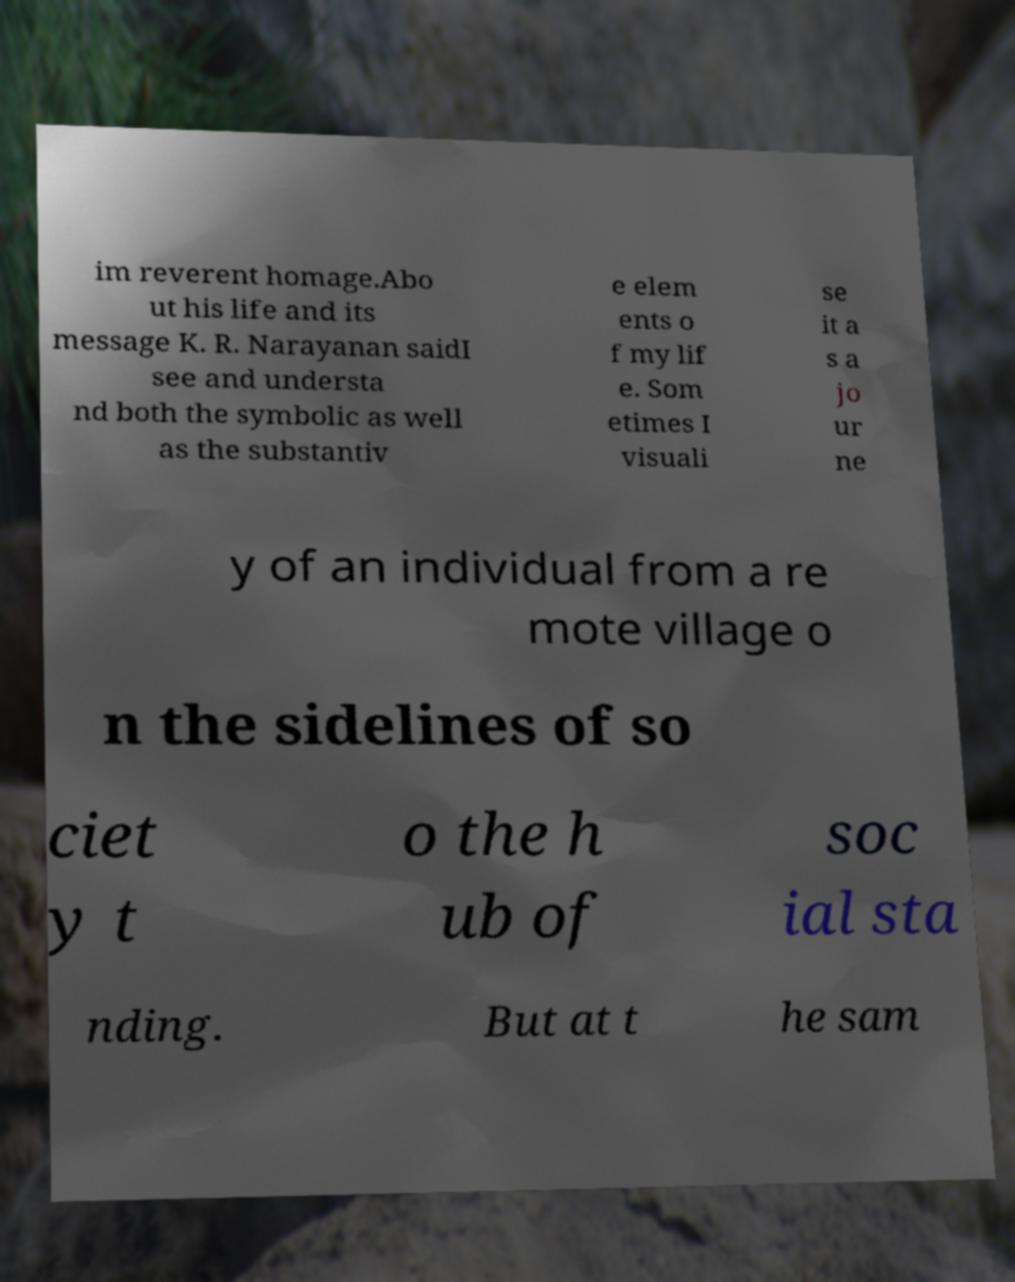There's text embedded in this image that I need extracted. Can you transcribe it verbatim? im reverent homage.Abo ut his life and its message K. R. Narayanan saidI see and understa nd both the symbolic as well as the substantiv e elem ents o f my lif e. Som etimes I visuali se it a s a jo ur ne y of an individual from a re mote village o n the sidelines of so ciet y t o the h ub of soc ial sta nding. But at t he sam 